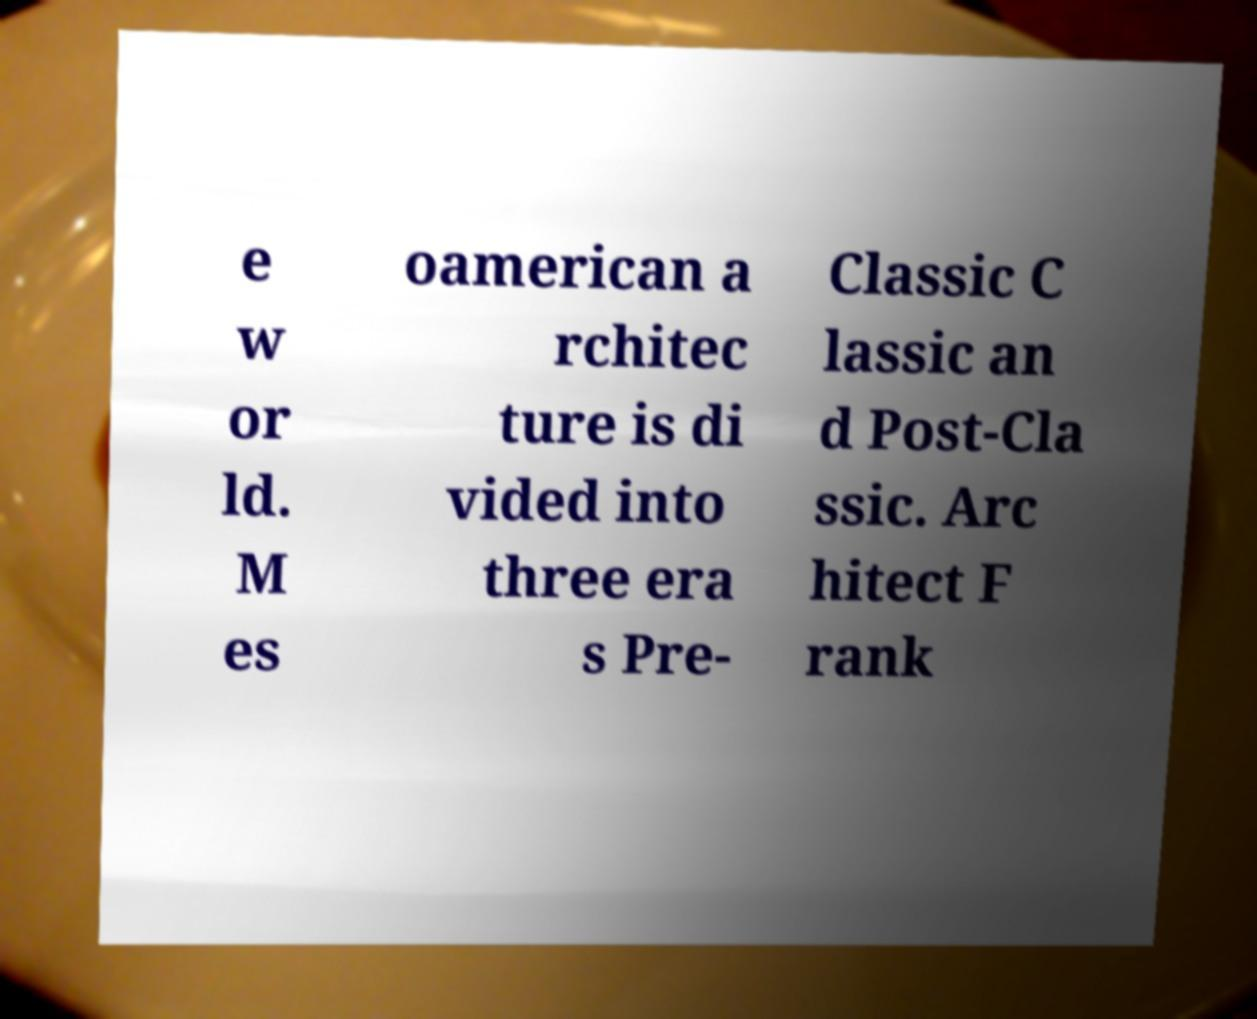Please read and relay the text visible in this image. What does it say? e w or ld. M es oamerican a rchitec ture is di vided into three era s Pre- Classic C lassic an d Post-Cla ssic. Arc hitect F rank 